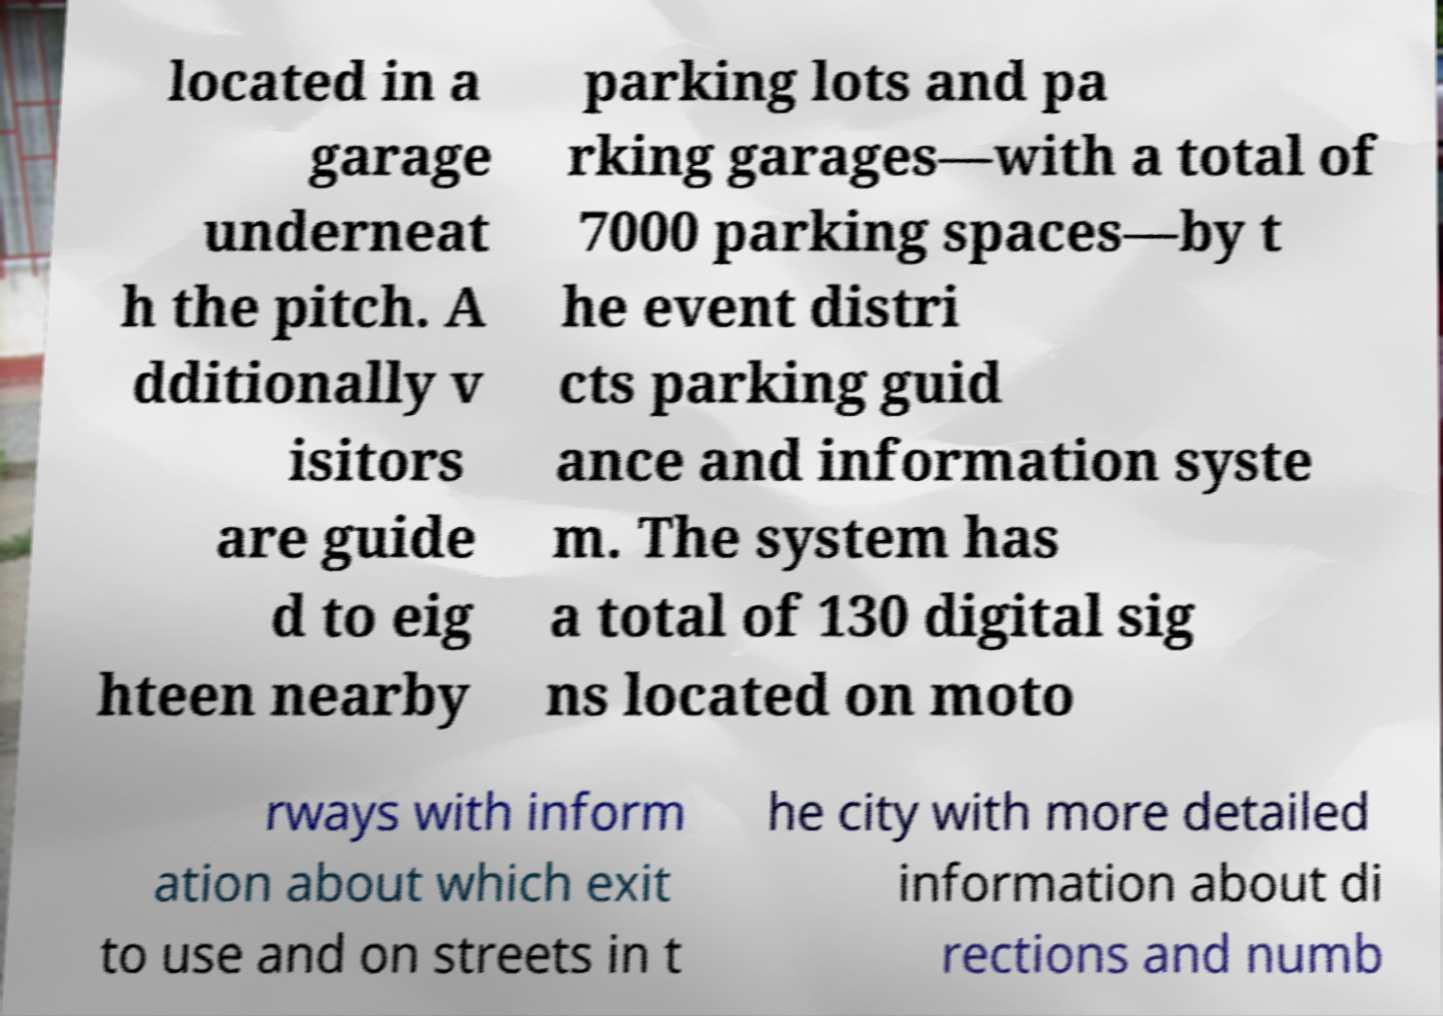Please identify and transcribe the text found in this image. located in a garage underneat h the pitch. A dditionally v isitors are guide d to eig hteen nearby parking lots and pa rking garages—with a total of 7000 parking spaces—by t he event distri cts parking guid ance and information syste m. The system has a total of 130 digital sig ns located on moto rways with inform ation about which exit to use and on streets in t he city with more detailed information about di rections and numb 